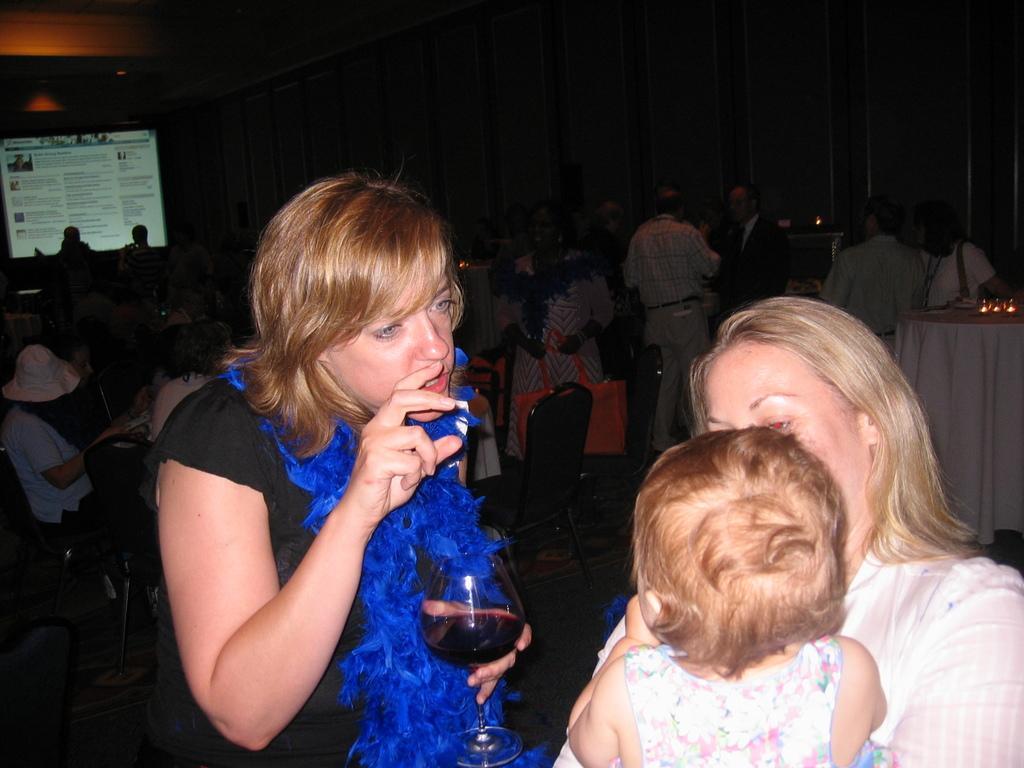Please provide a concise description of this image. On the right side of the image we can see a lady holding a baby in her hand, inside her we can see another lady talking and holding a wine glass in her hand. In the background we can see chairs, people and tables. On the left there is a screen. 